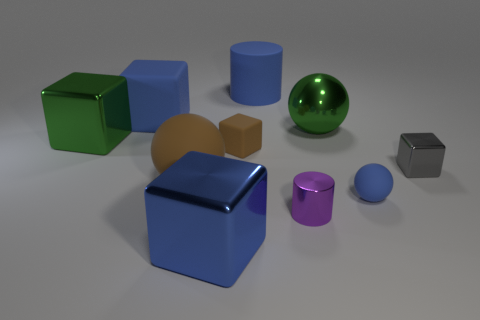Which objects in the image have the most reflective surfaces? The green and purple spheres exhibit the most reflective surfaces among the objects, showing clear light reflections and highlights on their surfaces. 